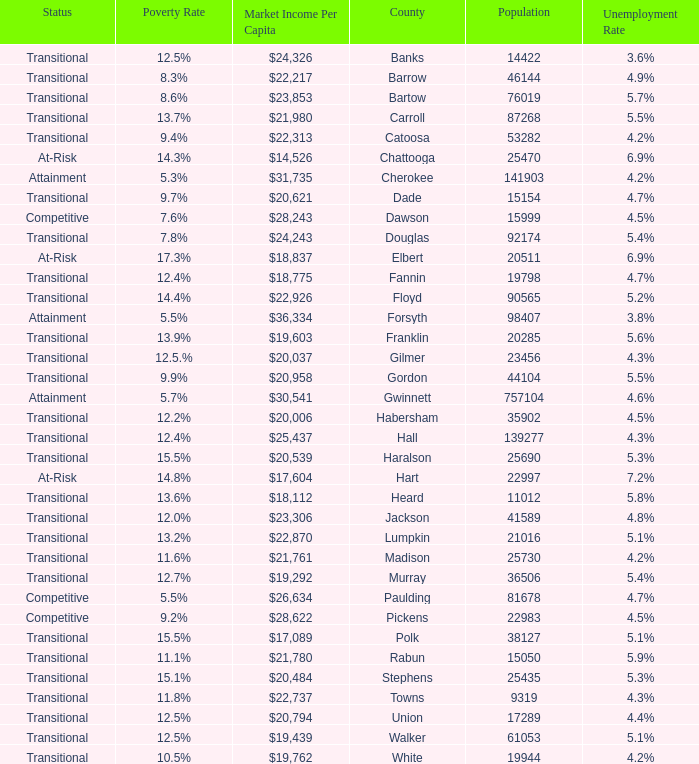Help me parse the entirety of this table. {'header': ['Status', 'Poverty Rate', 'Market Income Per Capita', 'County', 'Population', 'Unemployment Rate'], 'rows': [['Transitional', '12.5%', '$24,326', 'Banks', '14422', '3.6%'], ['Transitional', '8.3%', '$22,217', 'Barrow', '46144', '4.9%'], ['Transitional', '8.6%', '$23,853', 'Bartow', '76019', '5.7%'], ['Transitional', '13.7%', '$21,980', 'Carroll', '87268', '5.5%'], ['Transitional', '9.4%', '$22,313', 'Catoosa', '53282', '4.2%'], ['At-Risk', '14.3%', '$14,526', 'Chattooga', '25470', '6.9%'], ['Attainment', '5.3%', '$31,735', 'Cherokee', '141903', '4.2%'], ['Transitional', '9.7%', '$20,621', 'Dade', '15154', '4.7%'], ['Competitive', '7.6%', '$28,243', 'Dawson', '15999', '4.5%'], ['Transitional', '7.8%', '$24,243', 'Douglas', '92174', '5.4%'], ['At-Risk', '17.3%', '$18,837', 'Elbert', '20511', '6.9%'], ['Transitional', '12.4%', '$18,775', 'Fannin', '19798', '4.7%'], ['Transitional', '14.4%', '$22,926', 'Floyd', '90565', '5.2%'], ['Attainment', '5.5%', '$36,334', 'Forsyth', '98407', '3.8%'], ['Transitional', '13.9%', '$19,603', 'Franklin', '20285', '5.6%'], ['Transitional', '12.5.%', '$20,037', 'Gilmer', '23456', '4.3%'], ['Transitional', '9.9%', '$20,958', 'Gordon', '44104', '5.5%'], ['Attainment', '5.7%', '$30,541', 'Gwinnett', '757104', '4.6%'], ['Transitional', '12.2%', '$20,006', 'Habersham', '35902', '4.5%'], ['Transitional', '12.4%', '$25,437', 'Hall', '139277', '4.3%'], ['Transitional', '15.5%', '$20,539', 'Haralson', '25690', '5.3%'], ['At-Risk', '14.8%', '$17,604', 'Hart', '22997', '7.2%'], ['Transitional', '13.6%', '$18,112', 'Heard', '11012', '5.8%'], ['Transitional', '12.0%', '$23,306', 'Jackson', '41589', '4.8%'], ['Transitional', '13.2%', '$22,870', 'Lumpkin', '21016', '5.1%'], ['Transitional', '11.6%', '$21,761', 'Madison', '25730', '4.2%'], ['Transitional', '12.7%', '$19,292', 'Murray', '36506', '5.4%'], ['Competitive', '5.5%', '$26,634', 'Paulding', '81678', '4.7%'], ['Competitive', '9.2%', '$28,622', 'Pickens', '22983', '4.5%'], ['Transitional', '15.5%', '$17,089', 'Polk', '38127', '5.1%'], ['Transitional', '11.1%', '$21,780', 'Rabun', '15050', '5.9%'], ['Transitional', '15.1%', '$20,484', 'Stephens', '25435', '5.3%'], ['Transitional', '11.8%', '$22,737', 'Towns', '9319', '4.3%'], ['Transitional', '12.5%', '$20,794', 'Union', '17289', '4.4%'], ['Transitional', '12.5%', '$19,439', 'Walker', '61053', '5.1%'], ['Transitional', '10.5%', '$19,762', 'White', '19944', '4.2%']]} What is the status of the county that has a 17.3% poverty rate? At-Risk. 